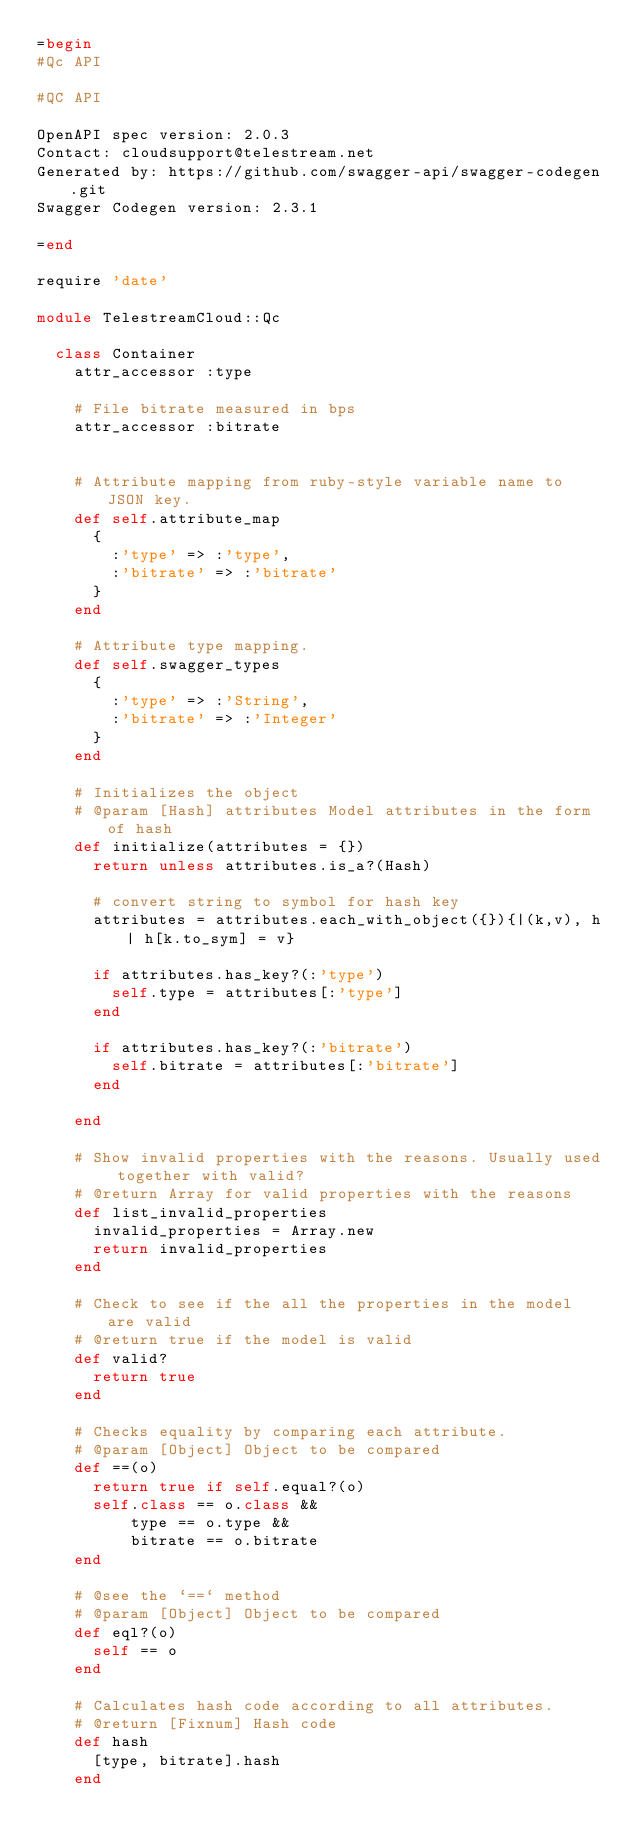<code> <loc_0><loc_0><loc_500><loc_500><_Ruby_>=begin
#Qc API

#QC API

OpenAPI spec version: 2.0.3
Contact: cloudsupport@telestream.net
Generated by: https://github.com/swagger-api/swagger-codegen.git
Swagger Codegen version: 2.3.1

=end

require 'date'

module TelestreamCloud::Qc

  class Container
    attr_accessor :type

    # File bitrate measured in bps
    attr_accessor :bitrate


    # Attribute mapping from ruby-style variable name to JSON key.
    def self.attribute_map
      {
        :'type' => :'type',
        :'bitrate' => :'bitrate'
      }
    end

    # Attribute type mapping.
    def self.swagger_types
      {
        :'type' => :'String',
        :'bitrate' => :'Integer'
      }
    end

    # Initializes the object
    # @param [Hash] attributes Model attributes in the form of hash
    def initialize(attributes = {})
      return unless attributes.is_a?(Hash)

      # convert string to symbol for hash key
      attributes = attributes.each_with_object({}){|(k,v), h| h[k.to_sym] = v}

      if attributes.has_key?(:'type')
        self.type = attributes[:'type']
      end

      if attributes.has_key?(:'bitrate')
        self.bitrate = attributes[:'bitrate']
      end

    end

    # Show invalid properties with the reasons. Usually used together with valid?
    # @return Array for valid properties with the reasons
    def list_invalid_properties
      invalid_properties = Array.new
      return invalid_properties
    end

    # Check to see if the all the properties in the model are valid
    # @return true if the model is valid
    def valid?
      return true
    end

    # Checks equality by comparing each attribute.
    # @param [Object] Object to be compared
    def ==(o)
      return true if self.equal?(o)
      self.class == o.class &&
          type == o.type &&
          bitrate == o.bitrate
    end

    # @see the `==` method
    # @param [Object] Object to be compared
    def eql?(o)
      self == o
    end

    # Calculates hash code according to all attributes.
    # @return [Fixnum] Hash code
    def hash
      [type, bitrate].hash
    end
</code> 